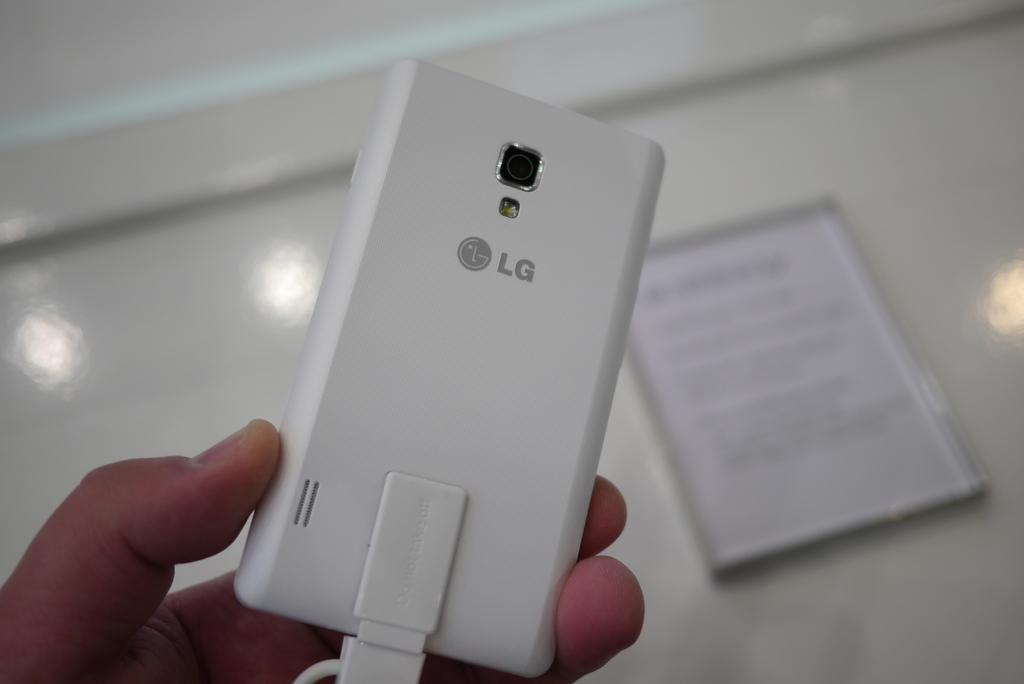Provide a one-sentence caption for the provided image. A hand holds an LG phone that is entirely white in color. 